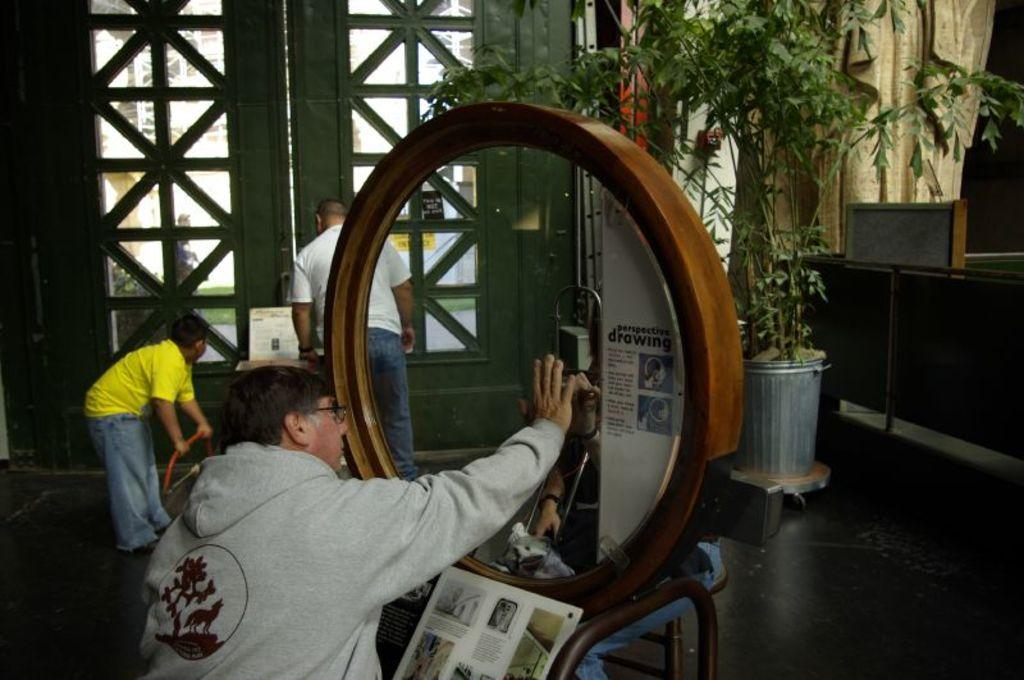What is the man in the image doing with his hand? The man is placing his hand on the glass. What type of clothing is the man wearing? The man is wearing a sweater. What can be seen on the right side of the image? There is a plant on the right side of the image. What is located on the left side of the image? There is a door on the left side of the image. Who else is present in the image besides the man with his hand on the glass? A man is observing the scene. What is the purpose of the grass in the image? There is no grass present in the image. How many boys are visible in the image? There is no mention of boys in the image; only two men are present. 